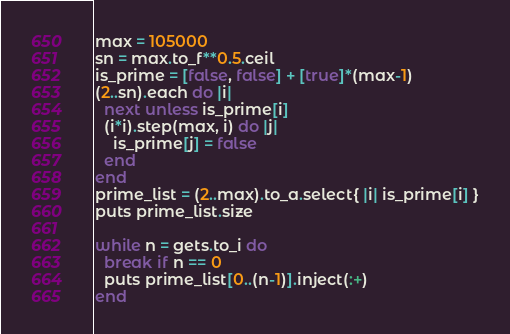Convert code to text. <code><loc_0><loc_0><loc_500><loc_500><_Ruby_>max = 105000
sn = max.to_f**0.5.ceil
is_prime = [false, false] + [true]*(max-1)
(2..sn).each do |i|
  next unless is_prime[i]
  (i*i).step(max, i) do |j|
    is_prime[j] = false
  end
end
prime_list = (2..max).to_a.select{ |i| is_prime[i] }
puts prime_list.size

while n = gets.to_i do
  break if n == 0
  puts prime_list[0..(n-1)].inject(:+)
end</code> 